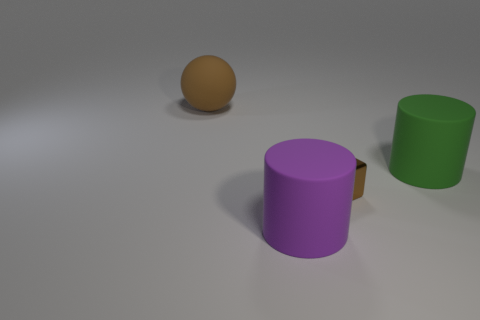Do the ball and the tiny cube that is in front of the big green matte thing have the same color?
Ensure brevity in your answer.  Yes. The matte object that is the same color as the tiny metallic cube is what size?
Your response must be concise. Large. What is the shape of the small object that is the same color as the ball?
Your answer should be very brief. Cube. There is a thing to the left of the large cylinder left of the big green object; what is its color?
Make the answer very short. Brown. There is a large rubber sphere left of the small brown cube; is its color the same as the cube?
Keep it short and to the point. Yes. There is a brown object that is in front of the large brown thing; what is its material?
Make the answer very short. Metal. What is the size of the green cylinder?
Your answer should be compact. Large. Is the brown object that is to the right of the big brown rubber sphere made of the same material as the big green thing?
Offer a very short reply. No. What number of large gray balls are there?
Make the answer very short. 0. What number of objects are either large green cylinders or cyan metal things?
Your answer should be compact. 1. 